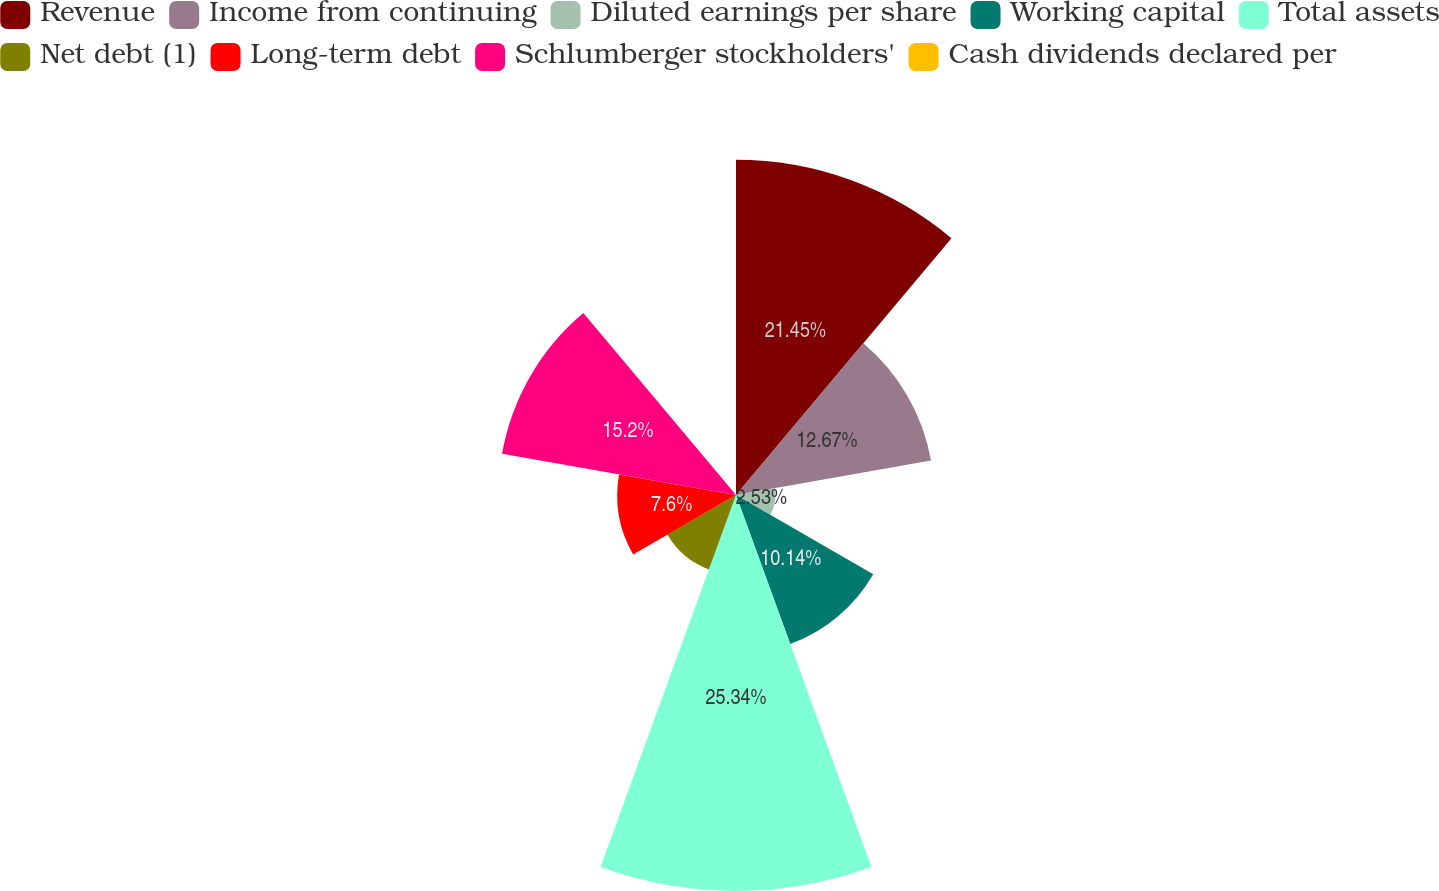<chart> <loc_0><loc_0><loc_500><loc_500><pie_chart><fcel>Revenue<fcel>Income from continuing<fcel>Diluted earnings per share<fcel>Working capital<fcel>Total assets<fcel>Net debt (1)<fcel>Long-term debt<fcel>Schlumberger stockholders'<fcel>Cash dividends declared per<nl><fcel>21.45%<fcel>12.67%<fcel>2.53%<fcel>10.14%<fcel>25.34%<fcel>5.07%<fcel>7.6%<fcel>15.2%<fcel>0.0%<nl></chart> 